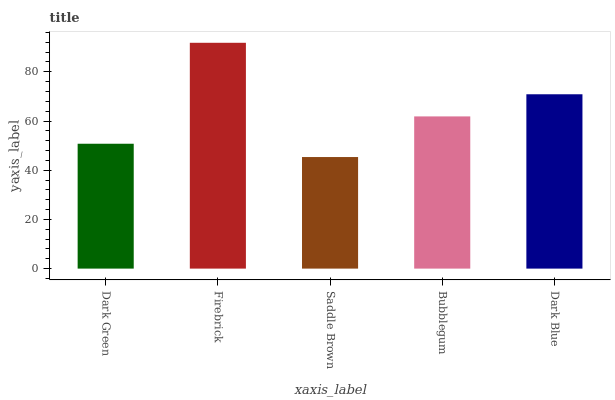Is Saddle Brown the minimum?
Answer yes or no. Yes. Is Firebrick the maximum?
Answer yes or no. Yes. Is Firebrick the minimum?
Answer yes or no. No. Is Saddle Brown the maximum?
Answer yes or no. No. Is Firebrick greater than Saddle Brown?
Answer yes or no. Yes. Is Saddle Brown less than Firebrick?
Answer yes or no. Yes. Is Saddle Brown greater than Firebrick?
Answer yes or no. No. Is Firebrick less than Saddle Brown?
Answer yes or no. No. Is Bubblegum the high median?
Answer yes or no. Yes. Is Bubblegum the low median?
Answer yes or no. Yes. Is Saddle Brown the high median?
Answer yes or no. No. Is Firebrick the low median?
Answer yes or no. No. 